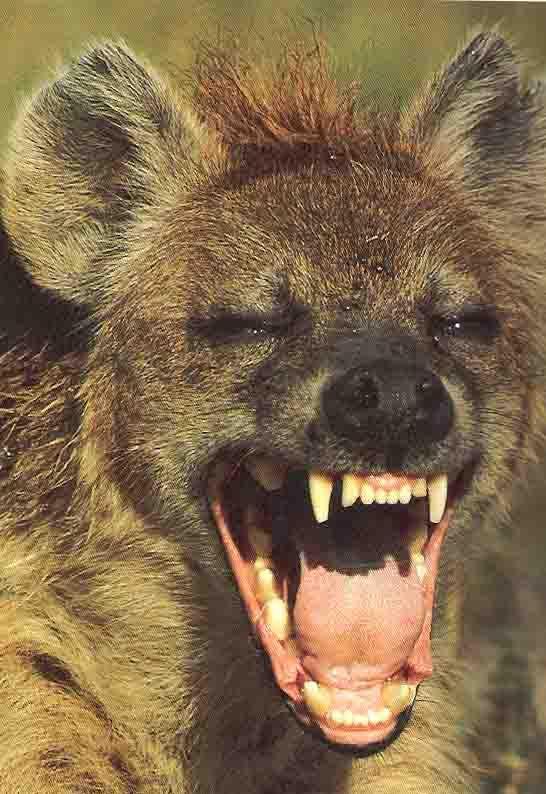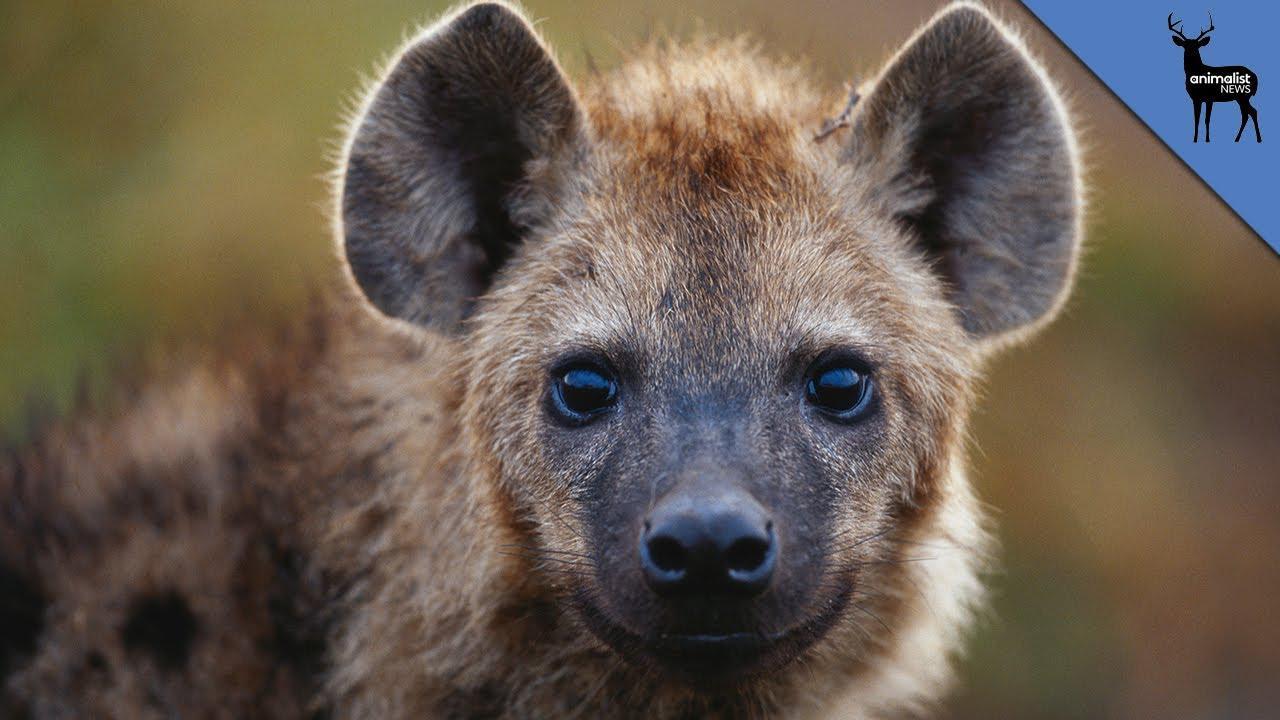The first image is the image on the left, the second image is the image on the right. For the images displayed, is the sentence "Exactly one hyena is showing his teeth and exactly one isn't." factually correct? Answer yes or no. Yes. 